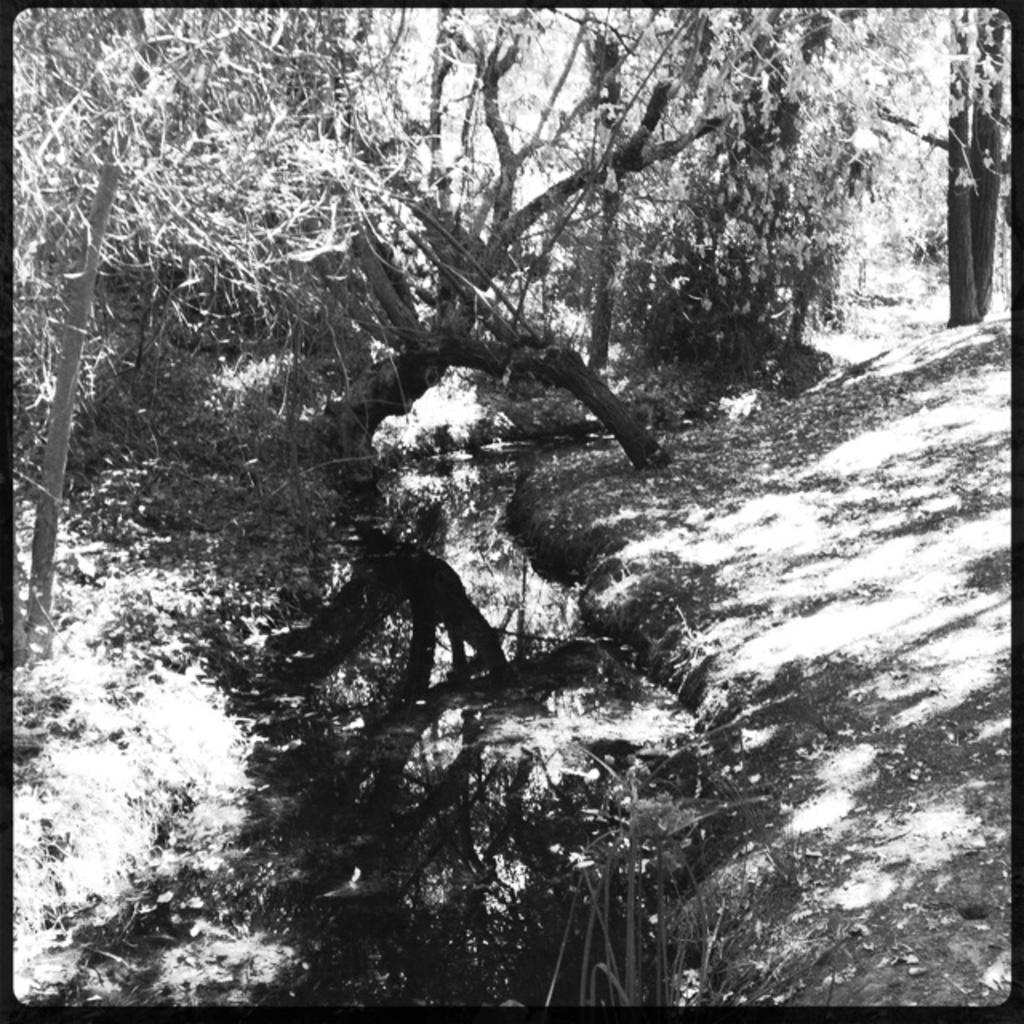Describe this image in one or two sentences. This is a black and white image and it is edited. This place is looking like a forest. Here I can see many trees on the ground. At the bottom there is a lake. 